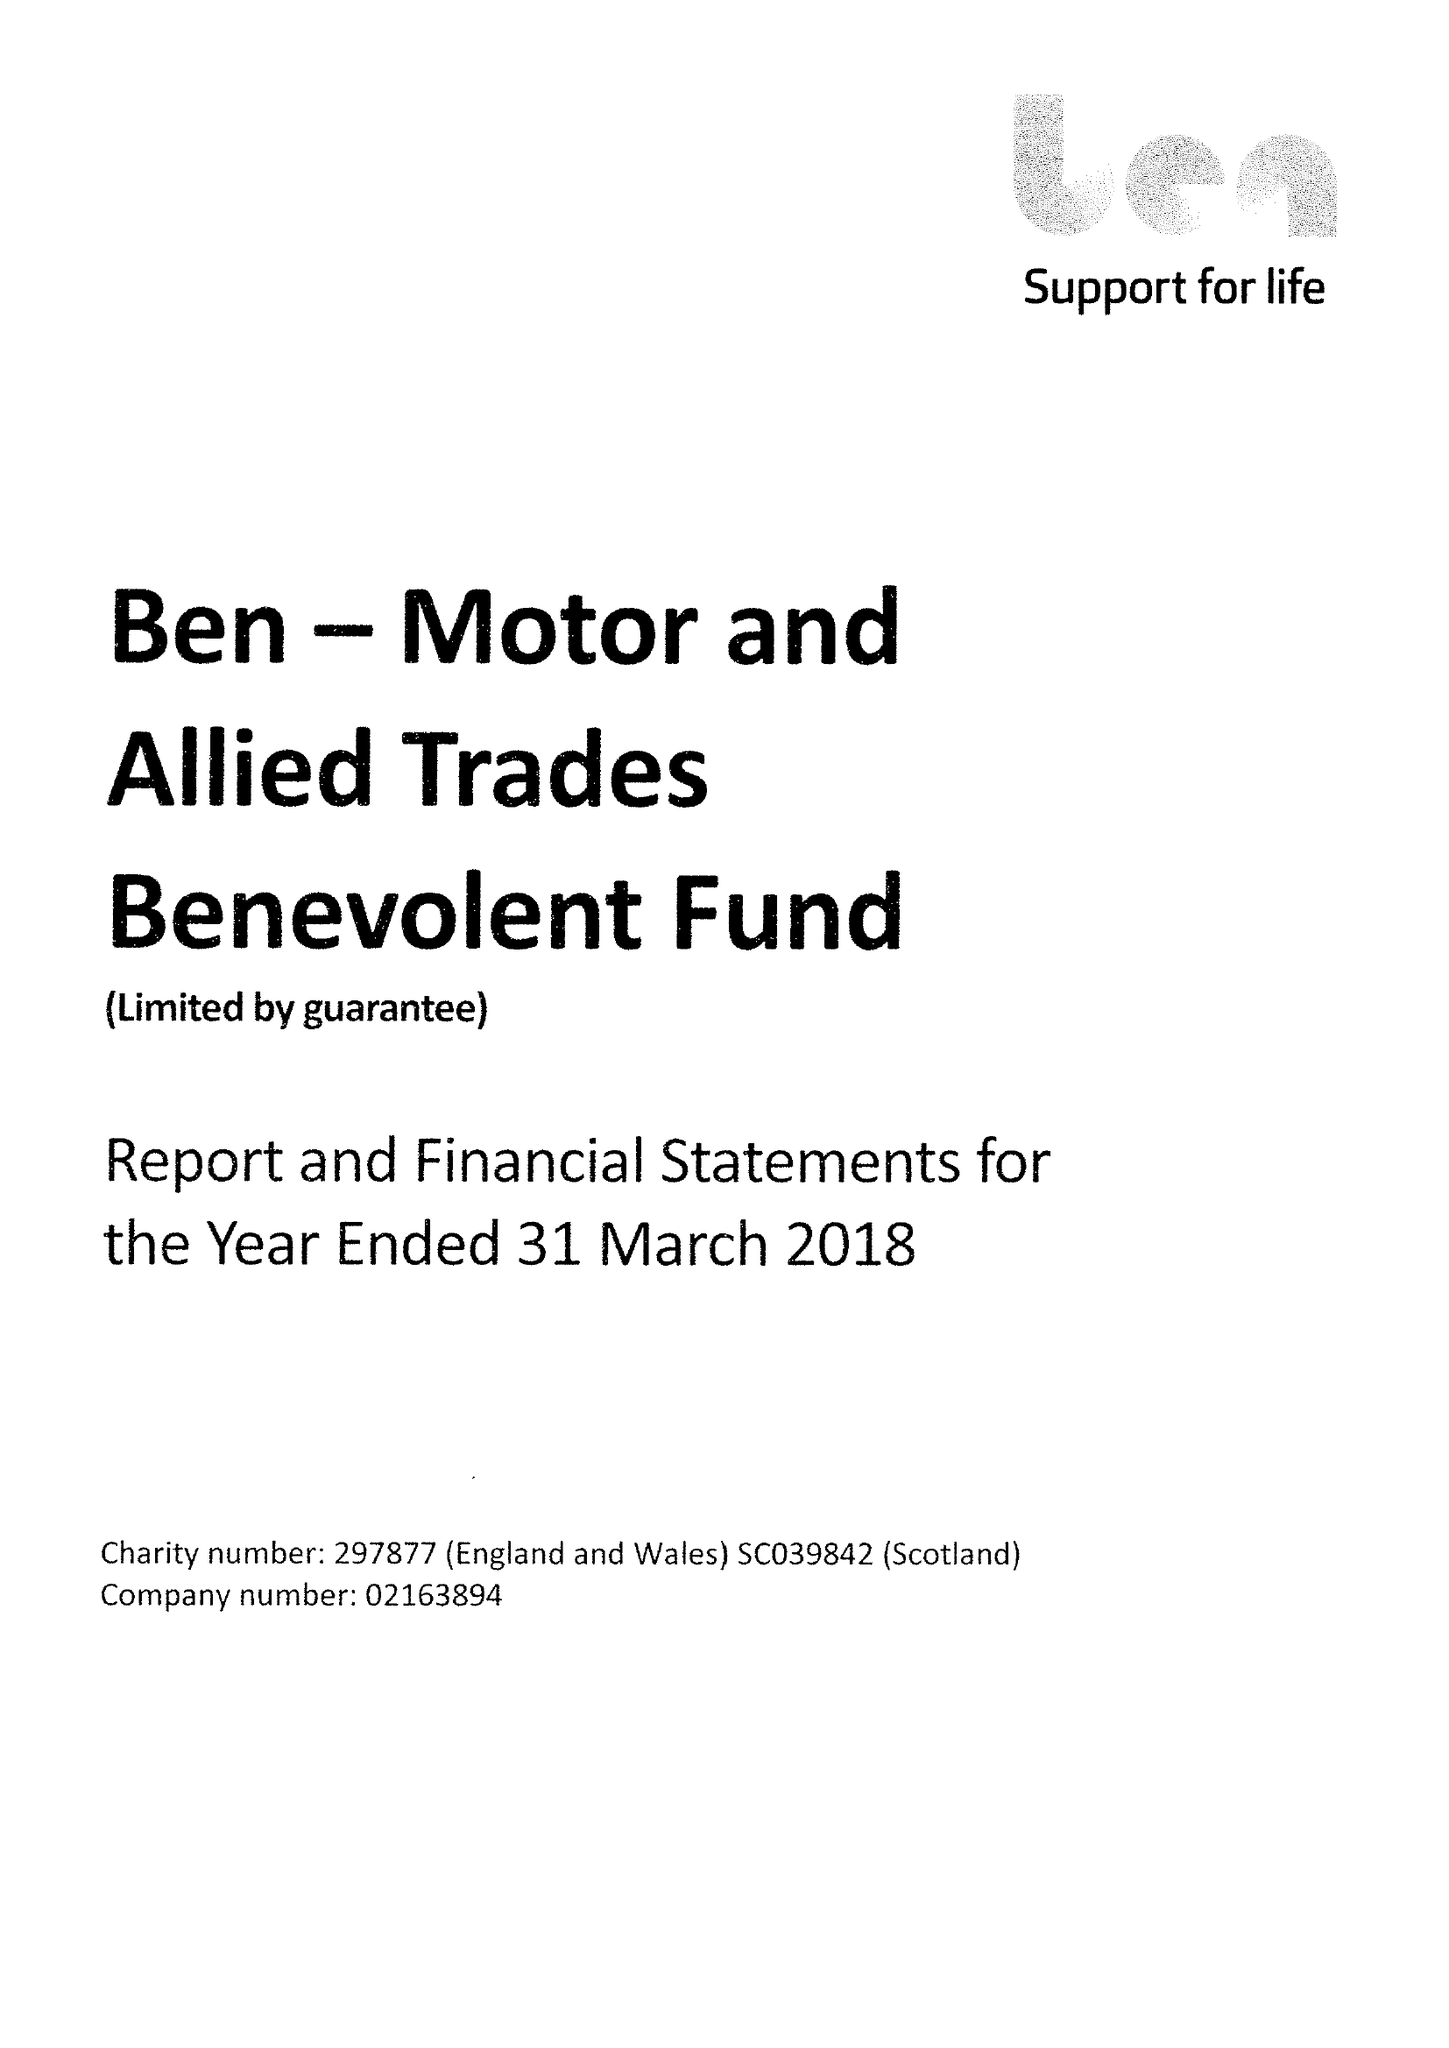What is the value for the address__post_town?
Answer the question using a single word or phrase. ASCOT 